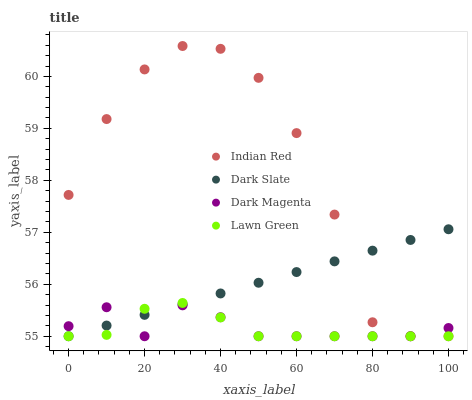Does Lawn Green have the minimum area under the curve?
Answer yes or no. Yes. Does Indian Red have the maximum area under the curve?
Answer yes or no. Yes. Does Dark Magenta have the minimum area under the curve?
Answer yes or no. No. Does Dark Magenta have the maximum area under the curve?
Answer yes or no. No. Is Dark Slate the smoothest?
Answer yes or no. Yes. Is Indian Red the roughest?
Answer yes or no. Yes. Is Dark Magenta the smoothest?
Answer yes or no. No. Is Dark Magenta the roughest?
Answer yes or no. No. Does Dark Slate have the lowest value?
Answer yes or no. Yes. Does Indian Red have the highest value?
Answer yes or no. Yes. Does Dark Magenta have the highest value?
Answer yes or no. No. Does Indian Red intersect Lawn Green?
Answer yes or no. Yes. Is Indian Red less than Lawn Green?
Answer yes or no. No. Is Indian Red greater than Lawn Green?
Answer yes or no. No. 